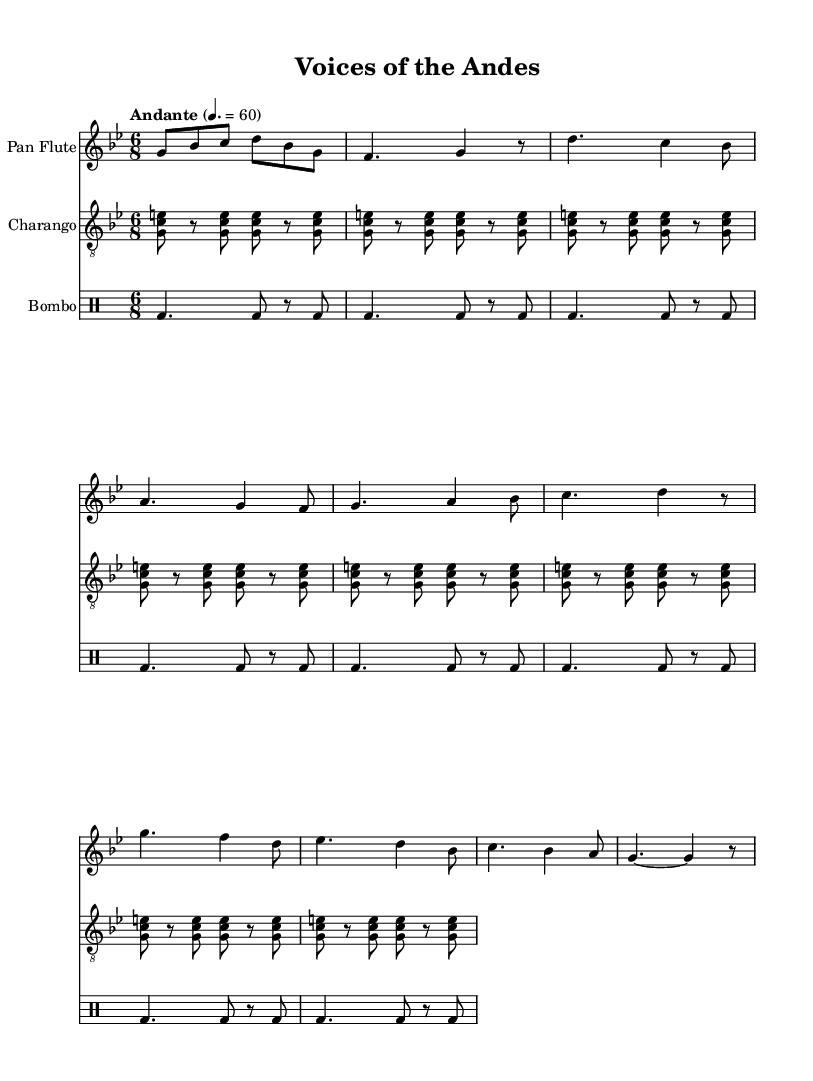What is the key signature of this music? The key signature is G minor, which includes two flats: B flat and E flat. This is indicated at the beginning of the sheet music where the key signature is shown.
Answer: G minor What is the time signature of the score? The time signature is 6/8, which can be identified at the beginning of the sheet music where the time signature is written as "6/8." This indicates a compound meter with six eighth-note beats per measure.
Answer: 6/8 What is the tempo marking for this piece? The tempo marking is "Andante," which suggests a moderate pace. This is indicated in the music score where the tempo is specified alongside a metronome marking.
Answer: Andante How many measures are there in the intro section? The intro section consists of two measures, which can be counted directly from the music notation at the start of the piece.
Answer: 2 What instruments are included in the score? The score includes three instruments: the Pan Flute, the Charango, and the Bombo. This is specified in the score layout where each instrument is labeled.
Answer: Pan Flute, Charango, Bombo What social theme is reflected in the lyrics? The lyrics reflect themes of ancestral voices and sacred mountains, suggesting a connection to cultural heritage and social justice. This is inferred from the lyrics provided, which emphasize tradition and identity.
Answer: Ancestral voices 